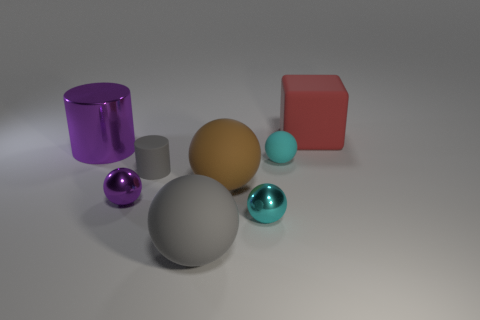Subtract all big brown matte spheres. How many spheres are left? 4 Subtract all brown cylinders. How many cyan spheres are left? 2 Add 1 tiny cylinders. How many objects exist? 9 Subtract all gray spheres. How many spheres are left? 4 Subtract all cylinders. How many objects are left? 6 Subtract all red spheres. Subtract all green cylinders. How many spheres are left? 5 Add 7 gray rubber cylinders. How many gray rubber cylinders are left? 8 Add 5 big purple metallic cylinders. How many big purple metallic cylinders exist? 6 Subtract 0 blue balls. How many objects are left? 8 Subtract all small balls. Subtract all big metallic objects. How many objects are left? 4 